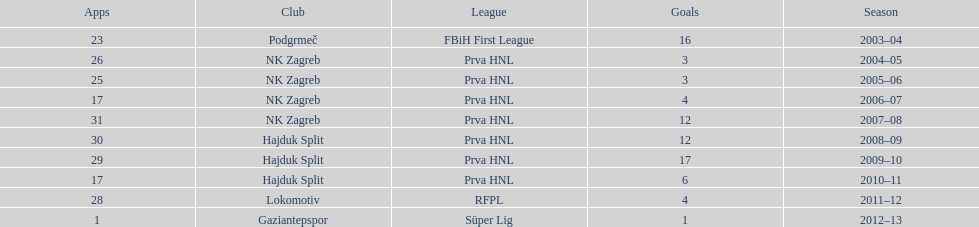Write the full table. {'header': ['Apps', 'Club', 'League', 'Goals', 'Season'], 'rows': [['23', 'Podgrmeč', 'FBiH First League', '16', '2003–04'], ['26', 'NK Zagreb', 'Prva HNL', '3', '2004–05'], ['25', 'NK Zagreb', 'Prva HNL', '3', '2005–06'], ['17', 'NK Zagreb', 'Prva HNL', '4', '2006–07'], ['31', 'NK Zagreb', 'Prva HNL', '12', '2007–08'], ['30', 'Hajduk Split', 'Prva HNL', '12', '2008–09'], ['29', 'Hajduk Split', 'Prva HNL', '17', '2009–10'], ['17', 'Hajduk Split', 'Prva HNL', '6', '2010–11'], ['28', 'Lokomotiv', 'RFPL', '4', '2011–12'], ['1', 'Gaziantepspor', 'Süper Lig', '1', '2012–13']]} What were the names of each club where more than 15 goals were scored in a single season? Podgrmeč, Hajduk Split. 